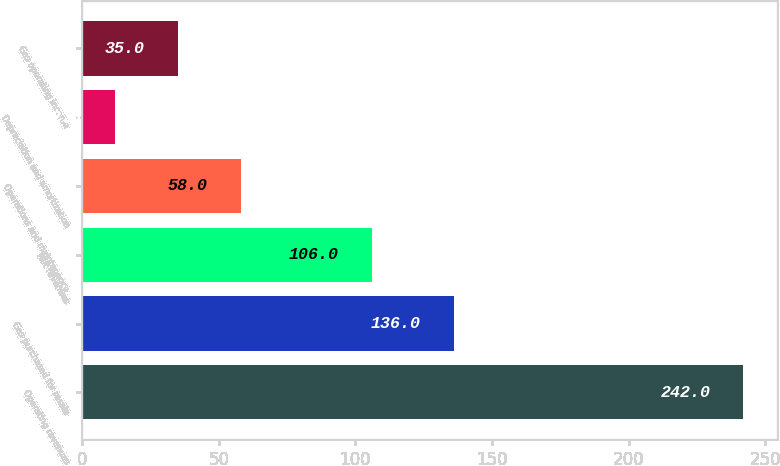<chart> <loc_0><loc_0><loc_500><loc_500><bar_chart><fcel>Operating revenues<fcel>Gas purchased for resale<fcel>Net revenues<fcel>Operations and maintenance<fcel>Depreciation and amortization<fcel>Gas operating income<nl><fcel>242<fcel>136<fcel>106<fcel>58<fcel>12<fcel>35<nl></chart> 